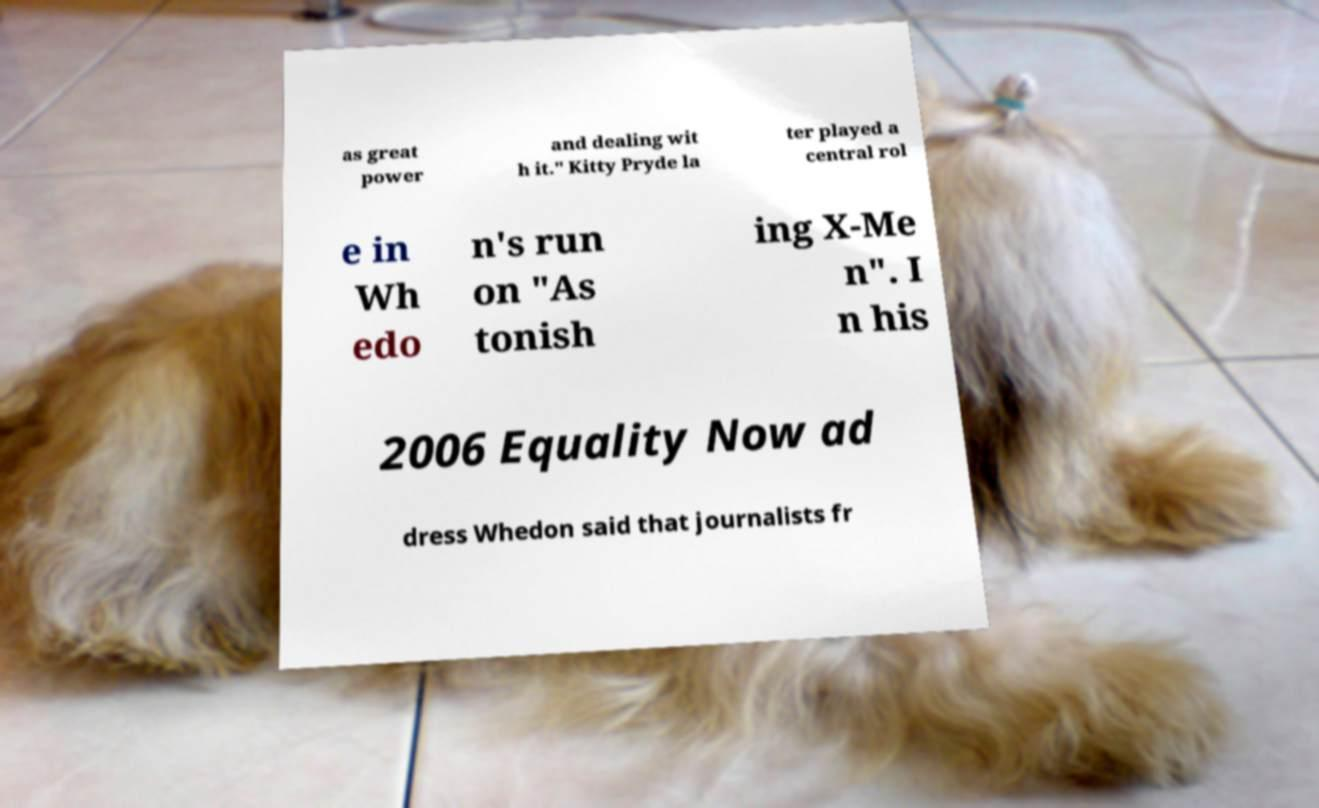Could you assist in decoding the text presented in this image and type it out clearly? as great power and dealing wit h it." Kitty Pryde la ter played a central rol e in Wh edo n's run on "As tonish ing X-Me n". I n his 2006 Equality Now ad dress Whedon said that journalists fr 